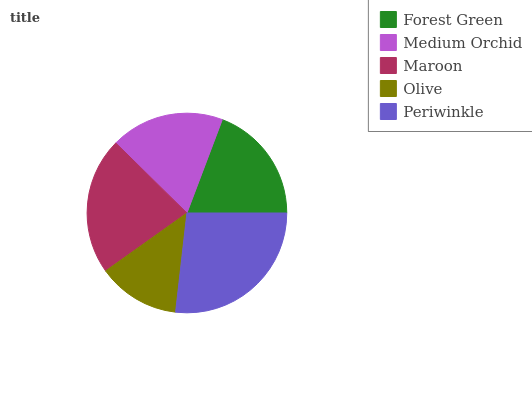Is Olive the minimum?
Answer yes or no. Yes. Is Periwinkle the maximum?
Answer yes or no. Yes. Is Medium Orchid the minimum?
Answer yes or no. No. Is Medium Orchid the maximum?
Answer yes or no. No. Is Forest Green greater than Medium Orchid?
Answer yes or no. Yes. Is Medium Orchid less than Forest Green?
Answer yes or no. Yes. Is Medium Orchid greater than Forest Green?
Answer yes or no. No. Is Forest Green less than Medium Orchid?
Answer yes or no. No. Is Forest Green the high median?
Answer yes or no. Yes. Is Forest Green the low median?
Answer yes or no. Yes. Is Medium Orchid the high median?
Answer yes or no. No. Is Maroon the low median?
Answer yes or no. No. 